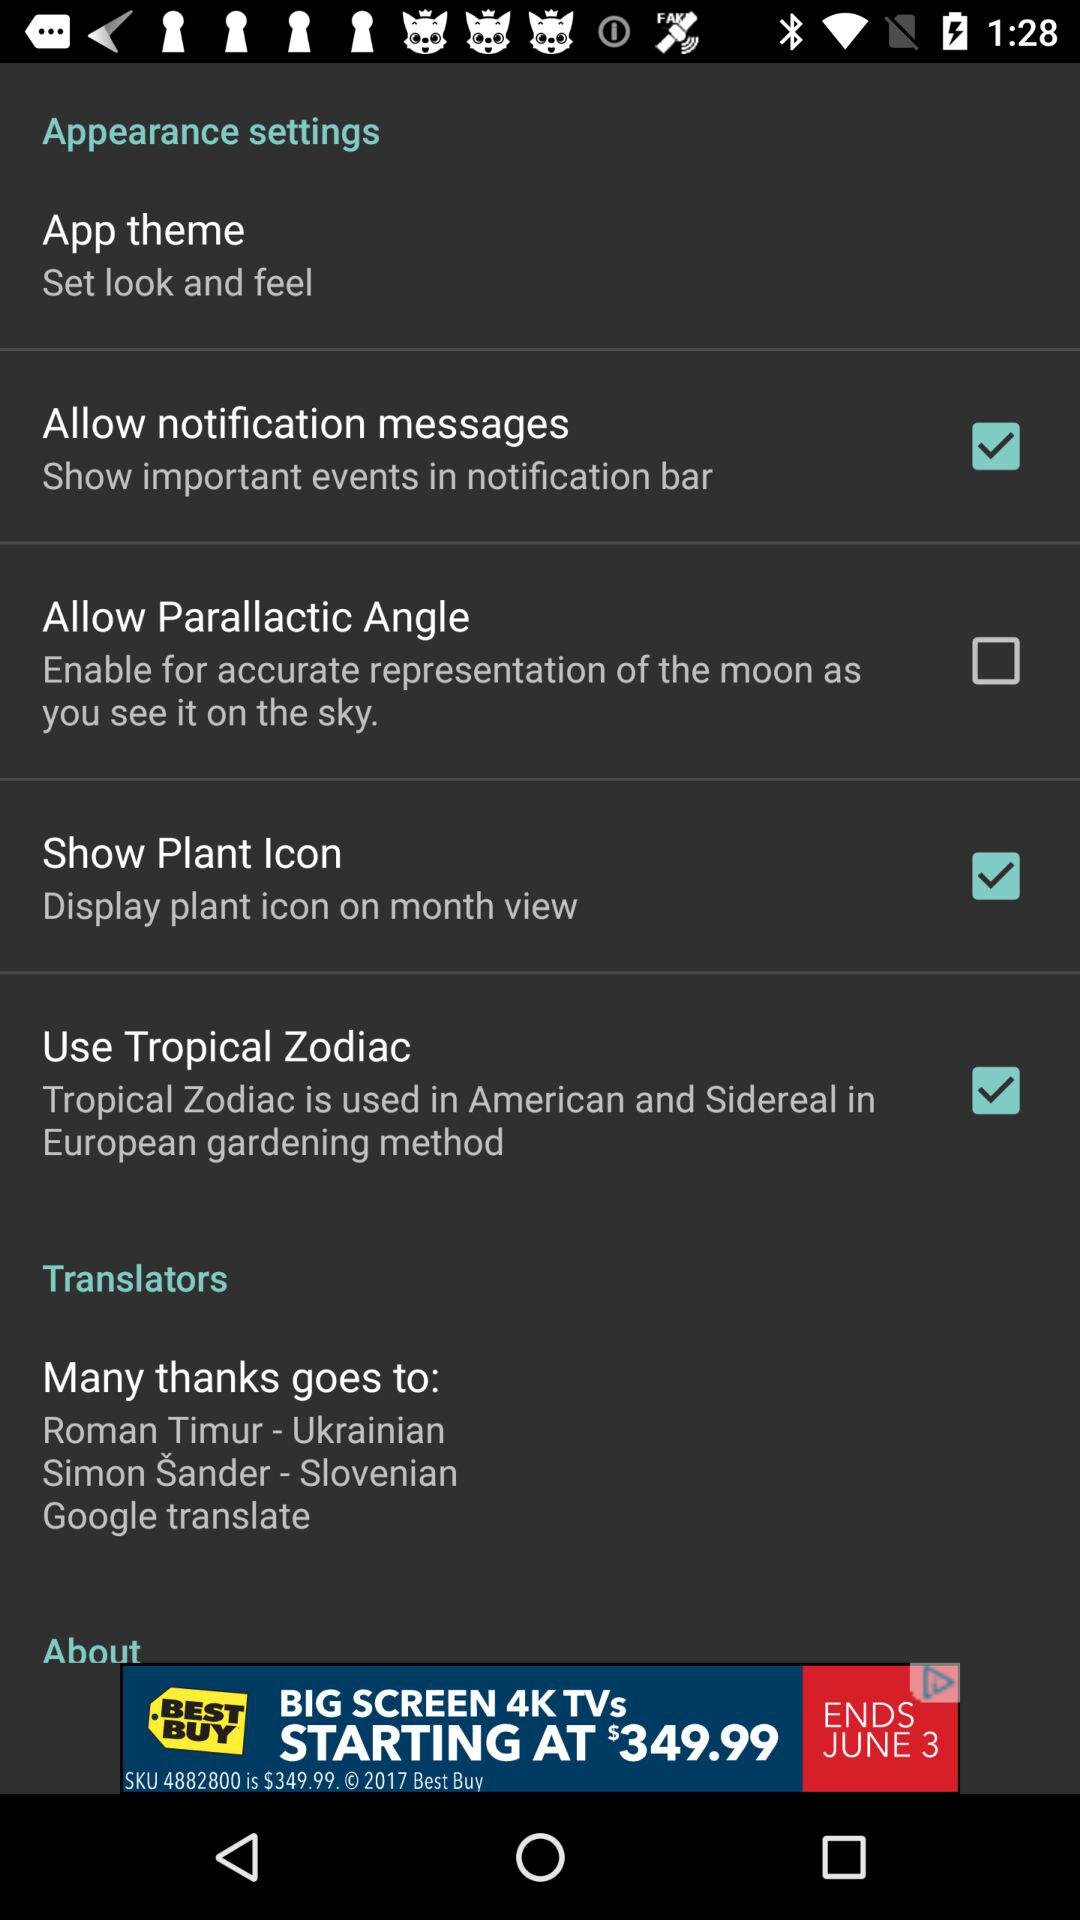What is the name of the application?
When the provided information is insufficient, respond with <no answer>. <no answer> 